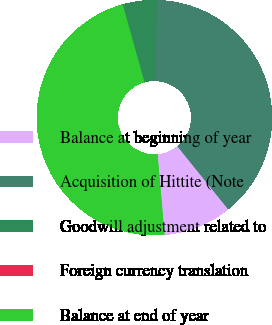Convert chart to OTSL. <chart><loc_0><loc_0><loc_500><loc_500><pie_chart><fcel>Balance at beginning of year<fcel>Acquisition of Hittite (Note<fcel>Goodwill adjustment related to<fcel>Foreign currency translation<fcel>Balance at end of year<nl><fcel>9.41%<fcel>38.86%<fcel>4.71%<fcel>0.0%<fcel>47.03%<nl></chart> 